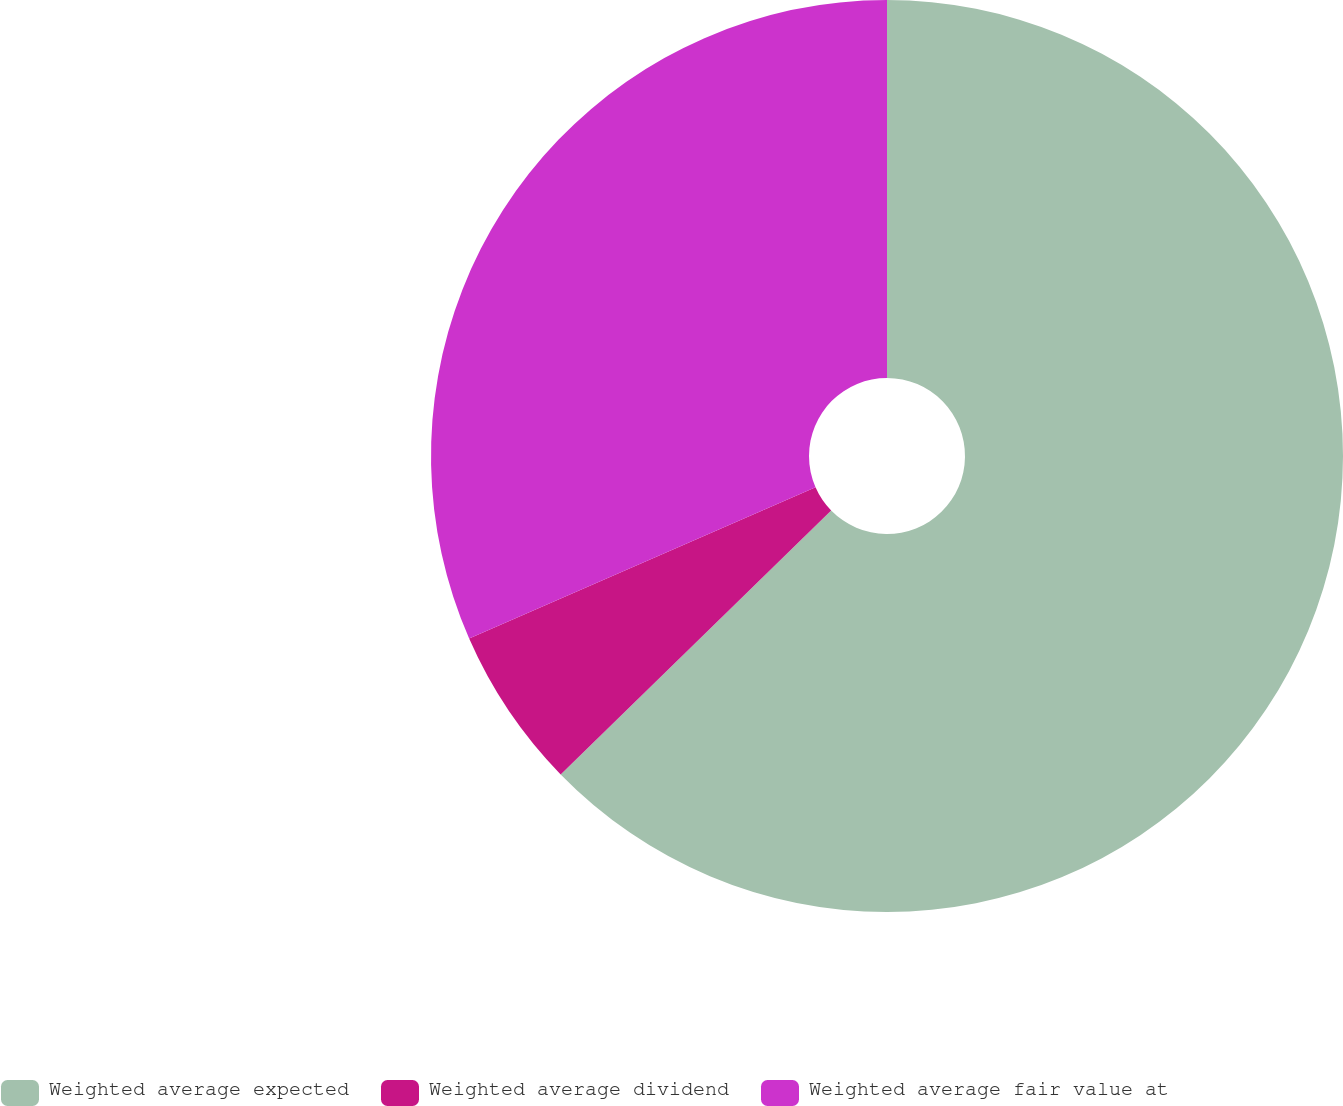Convert chart. <chart><loc_0><loc_0><loc_500><loc_500><pie_chart><fcel>Weighted average expected<fcel>Weighted average dividend<fcel>Weighted average fair value at<nl><fcel>62.7%<fcel>5.75%<fcel>31.56%<nl></chart> 